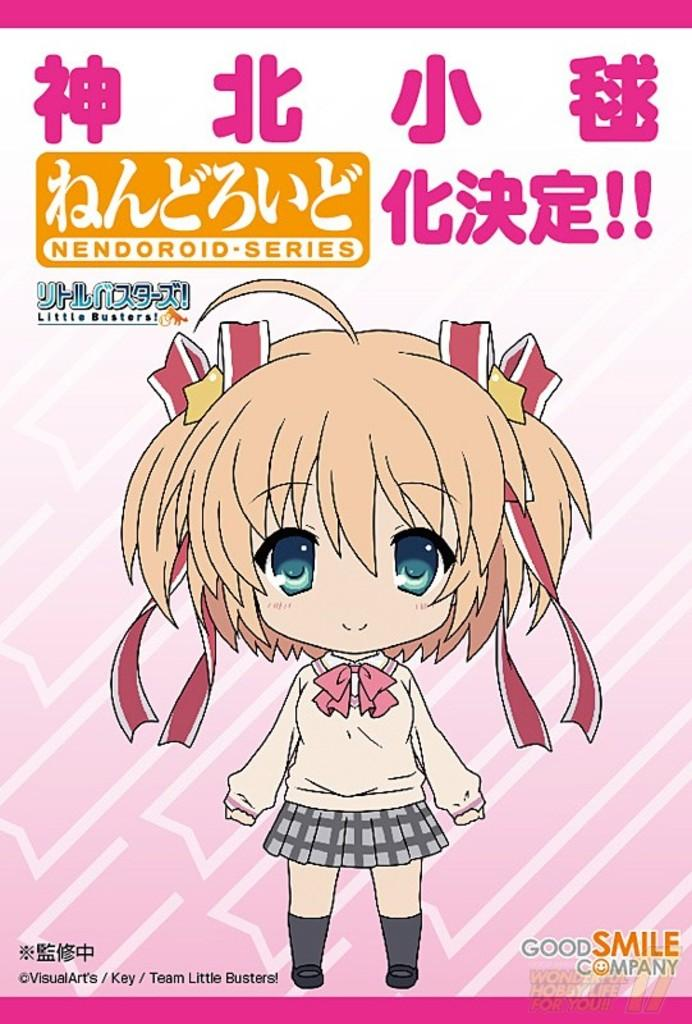What type of image is being described? The image is a poster. What is the main subject of the poster? There is a depiction of a girl on the poster. Are there any additional details or information on the poster? Yes, there is some information on the poster. What type of sign is the girl holding in the poster? There is no sign present in the poster; the girl is not holding anything. 